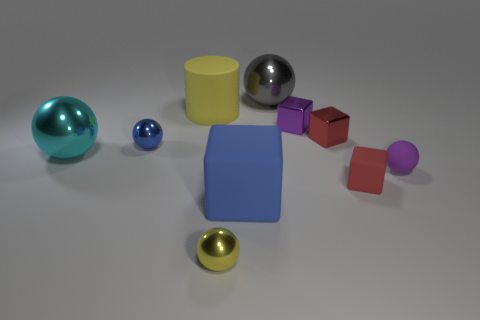Subtract all large gray shiny balls. How many balls are left? 4 Subtract all yellow spheres. How many spheres are left? 4 Subtract 1 spheres. How many spheres are left? 4 Subtract all green balls. Subtract all brown blocks. How many balls are left? 5 Subtract all blocks. How many objects are left? 6 Add 7 large gray shiny spheres. How many large gray shiny spheres are left? 8 Add 9 yellow matte cylinders. How many yellow matte cylinders exist? 10 Subtract 1 yellow cylinders. How many objects are left? 9 Subtract all purple matte cylinders. Subtract all tiny things. How many objects are left? 4 